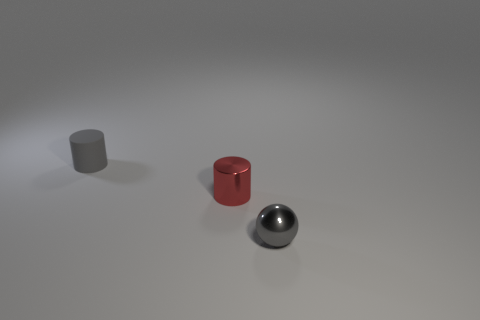Is there anything else that has the same material as the gray cylinder?
Keep it short and to the point. No. Does the red cylinder have the same material as the gray cylinder?
Ensure brevity in your answer.  No. How many objects are spheres or gray objects that are in front of the small matte object?
Ensure brevity in your answer.  1. There is a object that is the same color as the small sphere; what is its size?
Ensure brevity in your answer.  Small. There is a gray object that is behind the ball; what is its shape?
Offer a terse response. Cylinder. There is a tiny cylinder that is in front of the matte thing; is its color the same as the small metal sphere?
Offer a terse response. No. There is a small cylinder that is the same color as the metal sphere; what material is it?
Your answer should be compact. Rubber. There is a thing to the right of the red shiny cylinder; is its size the same as the red shiny cylinder?
Make the answer very short. Yes. Is there a tiny matte thing of the same color as the metallic sphere?
Give a very brief answer. Yes. There is a small thing to the left of the small red object; are there any tiny metallic objects behind it?
Keep it short and to the point. No. 